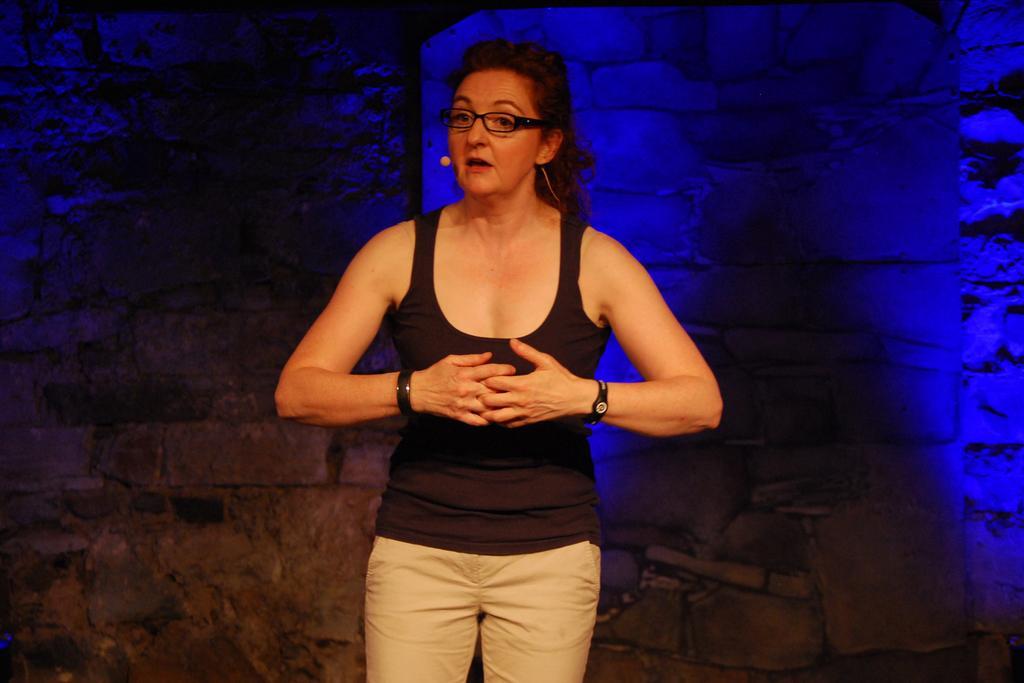Please provide a concise description of this image. In this image I can see a person standing wearing black shirt, cream pant. At the back I can see a wall. 